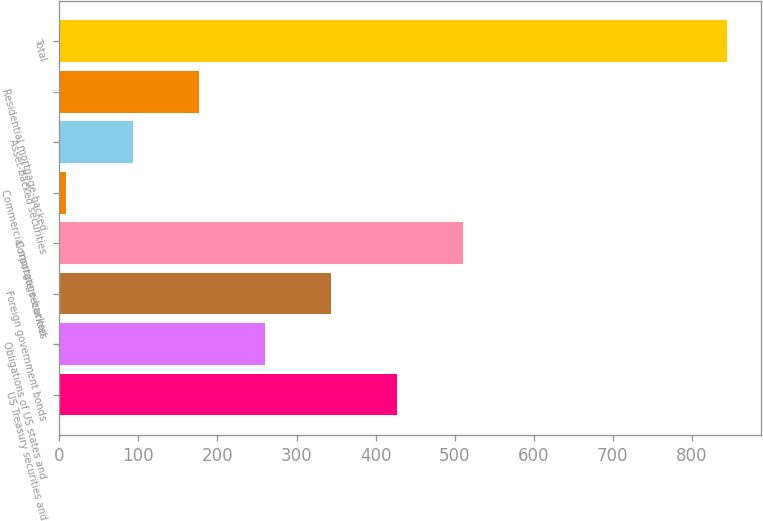Convert chart. <chart><loc_0><loc_0><loc_500><loc_500><bar_chart><fcel>US Treasury securities and<fcel>Obligations of US states and<fcel>Foreign government bonds<fcel>Corporate securities<fcel>Commercial mortgage-backed<fcel>Asset-backed securities<fcel>Residential mortgage-backed<fcel>Total<nl><fcel>427<fcel>259.8<fcel>343.4<fcel>510.6<fcel>9<fcel>92.6<fcel>176.2<fcel>845<nl></chart> 